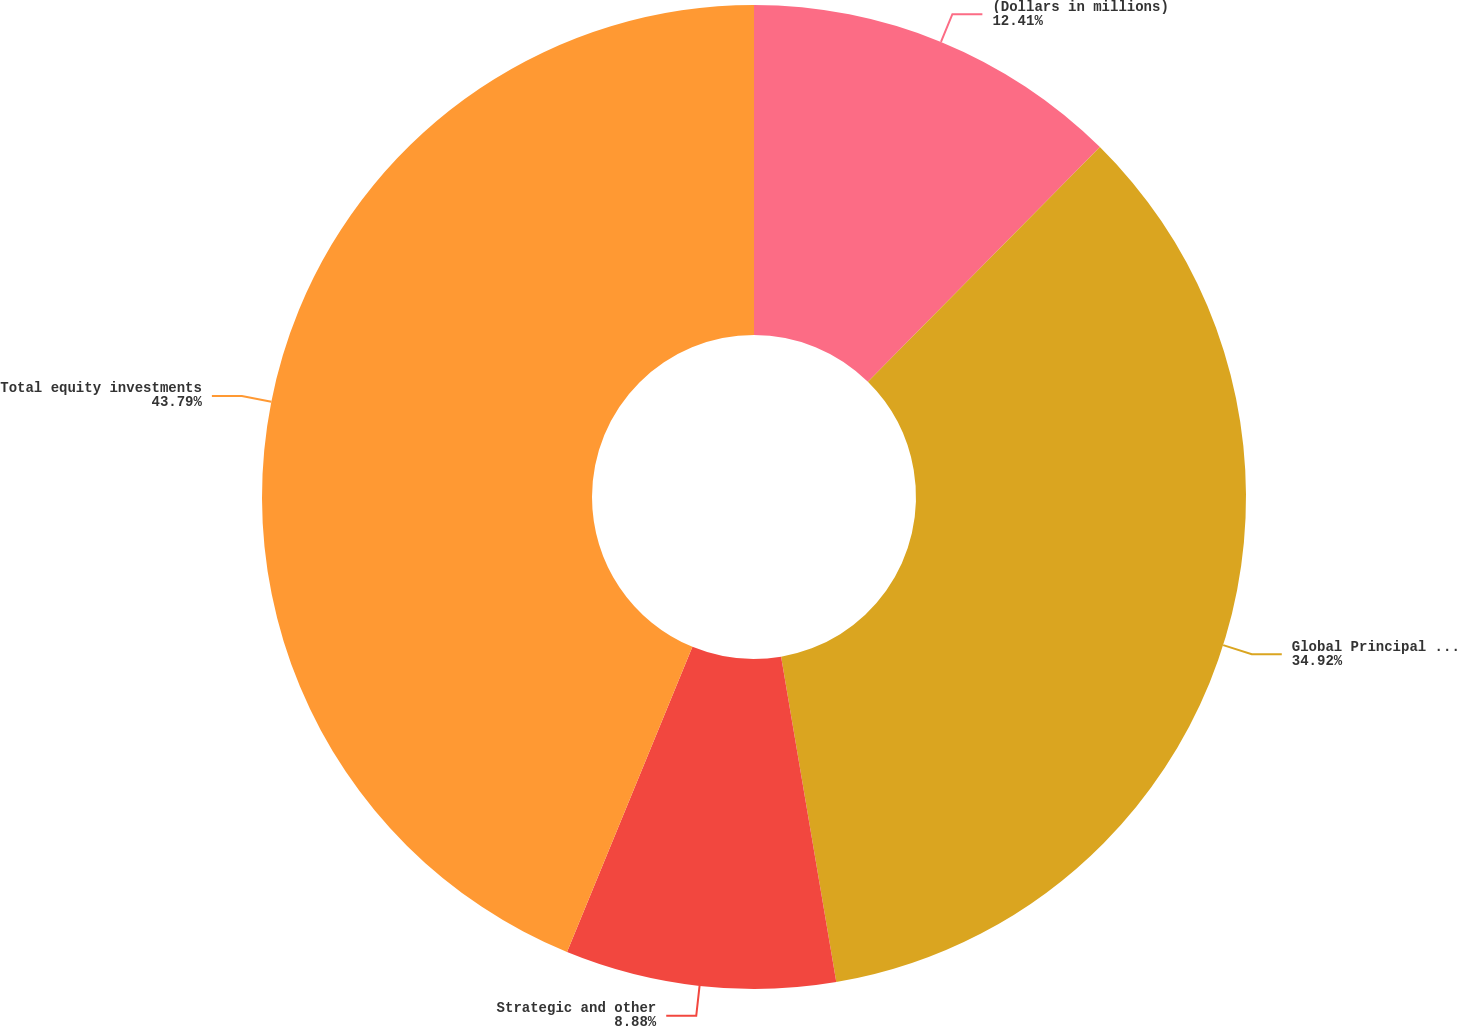Convert chart. <chart><loc_0><loc_0><loc_500><loc_500><pie_chart><fcel>(Dollars in millions)<fcel>Global Principal Investments<fcel>Strategic and other<fcel>Total equity investments<nl><fcel>12.41%<fcel>34.92%<fcel>8.88%<fcel>43.8%<nl></chart> 